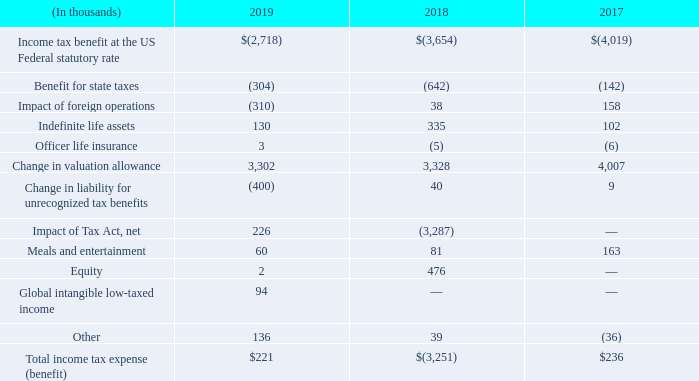The following table presents the principal components of the difference between the effective tax rate to the U.S. federal statutory income tax rate for the years ended March 31:
During fiscal 2018, we recorded a provisional tax benefit of approximately $3.3 million as a result of the enactment of the Tax Cuts and Jobs Act ("Tax Act") on December 22, 2017.
We completed the accounting for the Tax Act during Q3 fiscal 2019 and recorded an adjustment on December 31, 2018 of $0.2 million to increase our deferred tax liability associated with certain indefinite lived intangibles. We have elected to account for global intangible low-taxed income (GILTI) inclusions in the period in which they are incurred.
Our tax provision includes a provision for income taxes in certain foreign jurisdictions where subsidiaries are profitable, but only a minimal benefit is reflected related to U.S. and certain foreign tax losses due to the uncertainty of the ultimate realization of future benefits from these losses.
The 2019 tax provision results primarily from foreign tax expense, the reversal of reserves for uncertain tax positions and the completion of our accounting for the Tax Act. The 2019 tax provision differs from the statutory rate primarily due to the recognition of net operating losses as deferred tax assets, which were offset by increases in the valuation allowance, state taxes and other U.S. permanent book to tax differences.
The 2018 tax provision primarily results from a reduction in the deferred rate and the ability to offset indefinite lived deferred tax liabilities with certain deferred tax assets due to passage of the Tax Act. The 2018 effective rate differs from the statutory rate primarily due to the impact of the Tax Act, recognition of net operating losses as deferred tax assets, which were offset by increases in the valuation allowance, certain foreign and state tax effects including a benefit of $0.4 million related to a settlement with the California Franchise Tax Board and other U.S. permanent book to tax differences.
The 2017 tax provision primarily results from state taxes, taxes withheld in foreign jurisdictions and foreign tax expense. The 2017 tax provision differs from the statutory rate primarily due to the recognition of net operating losses as deferred tax assets, which were offset by increases in the valuation allowance, state taxes and other U.S. permanent book to tax differences.
What was the provisional tax benefit in 2018? Approximately $3.3 million. What was the adjustment against the tax act in Q3 2019? $0.2 million. What are the years included in the table? 2019, 2018, 2017. What was the increase / (decrease) in the benefit for state taxes from 2018 to 2019?
Answer scale should be: thousand. -304 - (- 642)
Answer: 338. What was the average indefinite life assets for 2017-2019?
Answer scale should be: thousand. (130 + 335 + 102) / 3
Answer: 189. What was the average Change in valuation allowance for 2017-2019?
Answer scale should be: thousand. (3,302 + 3,328 + 4,007) / 3
Answer: 3545.67. 